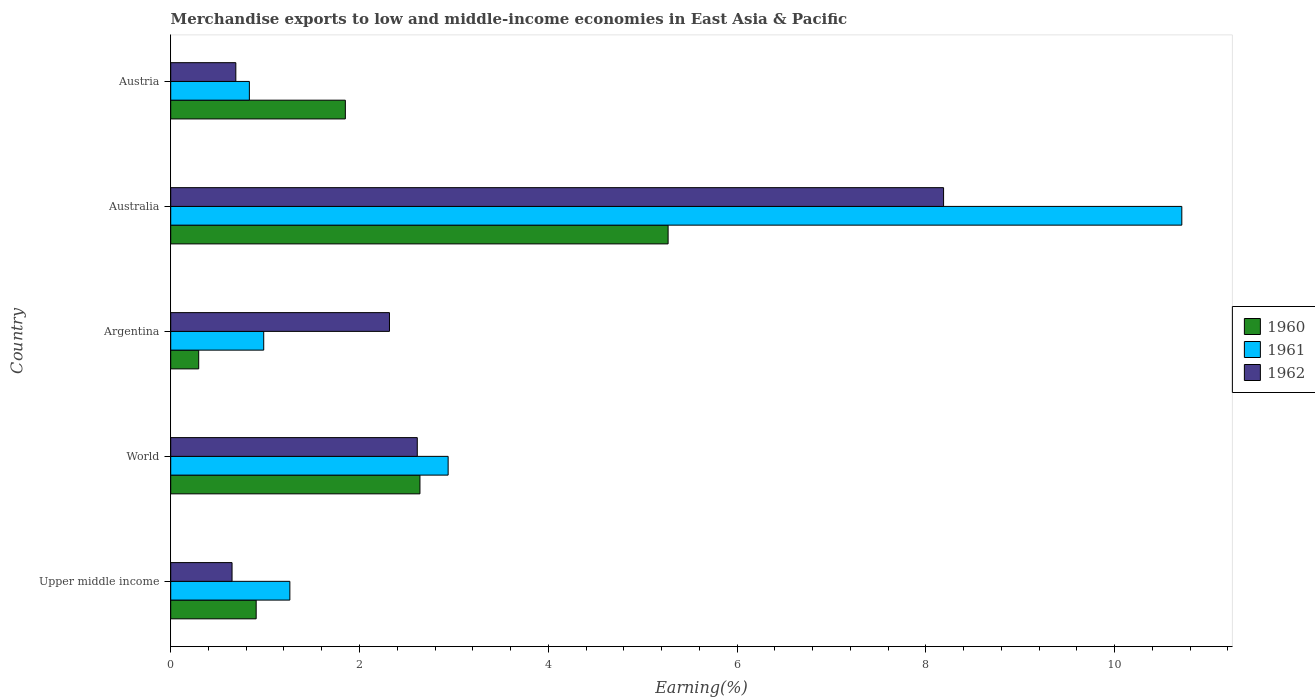How many groups of bars are there?
Your answer should be very brief. 5. Are the number of bars per tick equal to the number of legend labels?
Provide a succinct answer. Yes. Are the number of bars on each tick of the Y-axis equal?
Provide a succinct answer. Yes. How many bars are there on the 4th tick from the bottom?
Your answer should be compact. 3. In how many cases, is the number of bars for a given country not equal to the number of legend labels?
Provide a short and direct response. 0. What is the percentage of amount earned from merchandise exports in 1961 in Upper middle income?
Keep it short and to the point. 1.26. Across all countries, what is the maximum percentage of amount earned from merchandise exports in 1961?
Your response must be concise. 10.71. Across all countries, what is the minimum percentage of amount earned from merchandise exports in 1962?
Make the answer very short. 0.65. In which country was the percentage of amount earned from merchandise exports in 1961 minimum?
Make the answer very short. Austria. What is the total percentage of amount earned from merchandise exports in 1962 in the graph?
Keep it short and to the point. 14.46. What is the difference between the percentage of amount earned from merchandise exports in 1961 in Austria and that in Upper middle income?
Your answer should be very brief. -0.43. What is the difference between the percentage of amount earned from merchandise exports in 1962 in World and the percentage of amount earned from merchandise exports in 1961 in Austria?
Provide a short and direct response. 1.78. What is the average percentage of amount earned from merchandise exports in 1960 per country?
Keep it short and to the point. 2.19. What is the difference between the percentage of amount earned from merchandise exports in 1961 and percentage of amount earned from merchandise exports in 1962 in Argentina?
Make the answer very short. -1.33. What is the ratio of the percentage of amount earned from merchandise exports in 1961 in Austria to that in World?
Offer a terse response. 0.28. What is the difference between the highest and the second highest percentage of amount earned from merchandise exports in 1960?
Keep it short and to the point. 2.63. What is the difference between the highest and the lowest percentage of amount earned from merchandise exports in 1961?
Provide a short and direct response. 9.88. In how many countries, is the percentage of amount earned from merchandise exports in 1961 greater than the average percentage of amount earned from merchandise exports in 1961 taken over all countries?
Keep it short and to the point. 1. Is the sum of the percentage of amount earned from merchandise exports in 1961 in Australia and Austria greater than the maximum percentage of amount earned from merchandise exports in 1962 across all countries?
Your response must be concise. Yes. What does the 3rd bar from the bottom in Austria represents?
Make the answer very short. 1962. Are the values on the major ticks of X-axis written in scientific E-notation?
Ensure brevity in your answer.  No. Does the graph contain any zero values?
Your answer should be very brief. No. What is the title of the graph?
Ensure brevity in your answer.  Merchandise exports to low and middle-income economies in East Asia & Pacific. Does "1970" appear as one of the legend labels in the graph?
Your response must be concise. No. What is the label or title of the X-axis?
Your response must be concise. Earning(%). What is the label or title of the Y-axis?
Keep it short and to the point. Country. What is the Earning(%) of 1960 in Upper middle income?
Offer a very short reply. 0.91. What is the Earning(%) in 1961 in Upper middle income?
Give a very brief answer. 1.26. What is the Earning(%) of 1962 in Upper middle income?
Provide a short and direct response. 0.65. What is the Earning(%) of 1960 in World?
Offer a very short reply. 2.64. What is the Earning(%) in 1961 in World?
Give a very brief answer. 2.94. What is the Earning(%) in 1962 in World?
Provide a succinct answer. 2.61. What is the Earning(%) of 1960 in Argentina?
Your answer should be very brief. 0.3. What is the Earning(%) in 1961 in Argentina?
Your answer should be very brief. 0.99. What is the Earning(%) of 1962 in Argentina?
Ensure brevity in your answer.  2.32. What is the Earning(%) in 1960 in Australia?
Ensure brevity in your answer.  5.27. What is the Earning(%) in 1961 in Australia?
Ensure brevity in your answer.  10.71. What is the Earning(%) in 1962 in Australia?
Make the answer very short. 8.19. What is the Earning(%) of 1960 in Austria?
Give a very brief answer. 1.85. What is the Earning(%) of 1961 in Austria?
Make the answer very short. 0.83. What is the Earning(%) of 1962 in Austria?
Provide a short and direct response. 0.69. Across all countries, what is the maximum Earning(%) of 1960?
Your answer should be compact. 5.27. Across all countries, what is the maximum Earning(%) in 1961?
Ensure brevity in your answer.  10.71. Across all countries, what is the maximum Earning(%) in 1962?
Your answer should be very brief. 8.19. Across all countries, what is the minimum Earning(%) in 1960?
Provide a succinct answer. 0.3. Across all countries, what is the minimum Earning(%) in 1961?
Give a very brief answer. 0.83. Across all countries, what is the minimum Earning(%) of 1962?
Give a very brief answer. 0.65. What is the total Earning(%) of 1960 in the graph?
Offer a terse response. 10.96. What is the total Earning(%) in 1961 in the graph?
Provide a short and direct response. 16.73. What is the total Earning(%) of 1962 in the graph?
Make the answer very short. 14.46. What is the difference between the Earning(%) in 1960 in Upper middle income and that in World?
Your answer should be very brief. -1.74. What is the difference between the Earning(%) in 1961 in Upper middle income and that in World?
Make the answer very short. -1.68. What is the difference between the Earning(%) of 1962 in Upper middle income and that in World?
Keep it short and to the point. -1.96. What is the difference between the Earning(%) of 1960 in Upper middle income and that in Argentina?
Ensure brevity in your answer.  0.61. What is the difference between the Earning(%) of 1961 in Upper middle income and that in Argentina?
Make the answer very short. 0.28. What is the difference between the Earning(%) in 1962 in Upper middle income and that in Argentina?
Provide a succinct answer. -1.67. What is the difference between the Earning(%) in 1960 in Upper middle income and that in Australia?
Give a very brief answer. -4.36. What is the difference between the Earning(%) in 1961 in Upper middle income and that in Australia?
Make the answer very short. -9.45. What is the difference between the Earning(%) in 1962 in Upper middle income and that in Australia?
Offer a very short reply. -7.54. What is the difference between the Earning(%) of 1960 in Upper middle income and that in Austria?
Provide a succinct answer. -0.94. What is the difference between the Earning(%) in 1961 in Upper middle income and that in Austria?
Give a very brief answer. 0.43. What is the difference between the Earning(%) in 1962 in Upper middle income and that in Austria?
Keep it short and to the point. -0.04. What is the difference between the Earning(%) of 1960 in World and that in Argentina?
Your response must be concise. 2.34. What is the difference between the Earning(%) in 1961 in World and that in Argentina?
Give a very brief answer. 1.95. What is the difference between the Earning(%) of 1962 in World and that in Argentina?
Your response must be concise. 0.29. What is the difference between the Earning(%) in 1960 in World and that in Australia?
Offer a very short reply. -2.63. What is the difference between the Earning(%) in 1961 in World and that in Australia?
Your response must be concise. -7.77. What is the difference between the Earning(%) of 1962 in World and that in Australia?
Give a very brief answer. -5.58. What is the difference between the Earning(%) in 1960 in World and that in Austria?
Ensure brevity in your answer.  0.79. What is the difference between the Earning(%) in 1961 in World and that in Austria?
Provide a short and direct response. 2.11. What is the difference between the Earning(%) in 1962 in World and that in Austria?
Give a very brief answer. 1.92. What is the difference between the Earning(%) in 1960 in Argentina and that in Australia?
Provide a succinct answer. -4.97. What is the difference between the Earning(%) of 1961 in Argentina and that in Australia?
Your answer should be compact. -9.73. What is the difference between the Earning(%) in 1962 in Argentina and that in Australia?
Your answer should be compact. -5.87. What is the difference between the Earning(%) of 1960 in Argentina and that in Austria?
Offer a very short reply. -1.55. What is the difference between the Earning(%) of 1961 in Argentina and that in Austria?
Your answer should be very brief. 0.15. What is the difference between the Earning(%) of 1962 in Argentina and that in Austria?
Your answer should be compact. 1.63. What is the difference between the Earning(%) of 1960 in Australia and that in Austria?
Your answer should be compact. 3.42. What is the difference between the Earning(%) in 1961 in Australia and that in Austria?
Ensure brevity in your answer.  9.88. What is the difference between the Earning(%) of 1962 in Australia and that in Austria?
Your answer should be compact. 7.5. What is the difference between the Earning(%) of 1960 in Upper middle income and the Earning(%) of 1961 in World?
Offer a very short reply. -2.03. What is the difference between the Earning(%) of 1960 in Upper middle income and the Earning(%) of 1962 in World?
Offer a terse response. -1.71. What is the difference between the Earning(%) of 1961 in Upper middle income and the Earning(%) of 1962 in World?
Keep it short and to the point. -1.35. What is the difference between the Earning(%) of 1960 in Upper middle income and the Earning(%) of 1961 in Argentina?
Your response must be concise. -0.08. What is the difference between the Earning(%) of 1960 in Upper middle income and the Earning(%) of 1962 in Argentina?
Provide a succinct answer. -1.41. What is the difference between the Earning(%) of 1961 in Upper middle income and the Earning(%) of 1962 in Argentina?
Offer a terse response. -1.06. What is the difference between the Earning(%) in 1960 in Upper middle income and the Earning(%) in 1961 in Australia?
Your answer should be compact. -9.81. What is the difference between the Earning(%) of 1960 in Upper middle income and the Earning(%) of 1962 in Australia?
Your response must be concise. -7.28. What is the difference between the Earning(%) of 1961 in Upper middle income and the Earning(%) of 1962 in Australia?
Offer a terse response. -6.93. What is the difference between the Earning(%) in 1960 in Upper middle income and the Earning(%) in 1961 in Austria?
Keep it short and to the point. 0.07. What is the difference between the Earning(%) in 1960 in Upper middle income and the Earning(%) in 1962 in Austria?
Your answer should be very brief. 0.22. What is the difference between the Earning(%) of 1961 in Upper middle income and the Earning(%) of 1962 in Austria?
Keep it short and to the point. 0.57. What is the difference between the Earning(%) in 1960 in World and the Earning(%) in 1961 in Argentina?
Your response must be concise. 1.66. What is the difference between the Earning(%) in 1960 in World and the Earning(%) in 1962 in Argentina?
Your response must be concise. 0.32. What is the difference between the Earning(%) in 1961 in World and the Earning(%) in 1962 in Argentina?
Provide a succinct answer. 0.62. What is the difference between the Earning(%) of 1960 in World and the Earning(%) of 1961 in Australia?
Provide a short and direct response. -8.07. What is the difference between the Earning(%) in 1960 in World and the Earning(%) in 1962 in Australia?
Your answer should be very brief. -5.55. What is the difference between the Earning(%) of 1961 in World and the Earning(%) of 1962 in Australia?
Keep it short and to the point. -5.25. What is the difference between the Earning(%) in 1960 in World and the Earning(%) in 1961 in Austria?
Offer a terse response. 1.81. What is the difference between the Earning(%) in 1960 in World and the Earning(%) in 1962 in Austria?
Provide a succinct answer. 1.95. What is the difference between the Earning(%) of 1961 in World and the Earning(%) of 1962 in Austria?
Your answer should be very brief. 2.25. What is the difference between the Earning(%) in 1960 in Argentina and the Earning(%) in 1961 in Australia?
Offer a terse response. -10.42. What is the difference between the Earning(%) of 1960 in Argentina and the Earning(%) of 1962 in Australia?
Your response must be concise. -7.89. What is the difference between the Earning(%) of 1961 in Argentina and the Earning(%) of 1962 in Australia?
Provide a short and direct response. -7.2. What is the difference between the Earning(%) in 1960 in Argentina and the Earning(%) in 1961 in Austria?
Keep it short and to the point. -0.54. What is the difference between the Earning(%) of 1960 in Argentina and the Earning(%) of 1962 in Austria?
Provide a short and direct response. -0.39. What is the difference between the Earning(%) of 1961 in Argentina and the Earning(%) of 1962 in Austria?
Ensure brevity in your answer.  0.3. What is the difference between the Earning(%) in 1960 in Australia and the Earning(%) in 1961 in Austria?
Give a very brief answer. 4.44. What is the difference between the Earning(%) of 1960 in Australia and the Earning(%) of 1962 in Austria?
Ensure brevity in your answer.  4.58. What is the difference between the Earning(%) of 1961 in Australia and the Earning(%) of 1962 in Austria?
Provide a short and direct response. 10.02. What is the average Earning(%) of 1960 per country?
Your response must be concise. 2.19. What is the average Earning(%) in 1961 per country?
Offer a terse response. 3.35. What is the average Earning(%) in 1962 per country?
Your answer should be very brief. 2.89. What is the difference between the Earning(%) of 1960 and Earning(%) of 1961 in Upper middle income?
Offer a terse response. -0.36. What is the difference between the Earning(%) of 1960 and Earning(%) of 1962 in Upper middle income?
Ensure brevity in your answer.  0.26. What is the difference between the Earning(%) in 1961 and Earning(%) in 1962 in Upper middle income?
Offer a terse response. 0.61. What is the difference between the Earning(%) in 1960 and Earning(%) in 1961 in World?
Your answer should be very brief. -0.3. What is the difference between the Earning(%) of 1960 and Earning(%) of 1962 in World?
Ensure brevity in your answer.  0.03. What is the difference between the Earning(%) of 1961 and Earning(%) of 1962 in World?
Keep it short and to the point. 0.33. What is the difference between the Earning(%) in 1960 and Earning(%) in 1961 in Argentina?
Ensure brevity in your answer.  -0.69. What is the difference between the Earning(%) of 1960 and Earning(%) of 1962 in Argentina?
Keep it short and to the point. -2.02. What is the difference between the Earning(%) of 1961 and Earning(%) of 1962 in Argentina?
Provide a short and direct response. -1.33. What is the difference between the Earning(%) of 1960 and Earning(%) of 1961 in Australia?
Offer a terse response. -5.44. What is the difference between the Earning(%) in 1960 and Earning(%) in 1962 in Australia?
Keep it short and to the point. -2.92. What is the difference between the Earning(%) in 1961 and Earning(%) in 1962 in Australia?
Offer a terse response. 2.52. What is the difference between the Earning(%) in 1960 and Earning(%) in 1961 in Austria?
Your answer should be compact. 1.02. What is the difference between the Earning(%) of 1960 and Earning(%) of 1962 in Austria?
Give a very brief answer. 1.16. What is the difference between the Earning(%) of 1961 and Earning(%) of 1962 in Austria?
Your response must be concise. 0.14. What is the ratio of the Earning(%) of 1960 in Upper middle income to that in World?
Your answer should be very brief. 0.34. What is the ratio of the Earning(%) in 1961 in Upper middle income to that in World?
Your answer should be very brief. 0.43. What is the ratio of the Earning(%) in 1962 in Upper middle income to that in World?
Your response must be concise. 0.25. What is the ratio of the Earning(%) of 1960 in Upper middle income to that in Argentina?
Your answer should be compact. 3.05. What is the ratio of the Earning(%) in 1961 in Upper middle income to that in Argentina?
Offer a terse response. 1.28. What is the ratio of the Earning(%) in 1962 in Upper middle income to that in Argentina?
Your response must be concise. 0.28. What is the ratio of the Earning(%) of 1960 in Upper middle income to that in Australia?
Provide a short and direct response. 0.17. What is the ratio of the Earning(%) in 1961 in Upper middle income to that in Australia?
Make the answer very short. 0.12. What is the ratio of the Earning(%) of 1962 in Upper middle income to that in Australia?
Your answer should be compact. 0.08. What is the ratio of the Earning(%) in 1960 in Upper middle income to that in Austria?
Ensure brevity in your answer.  0.49. What is the ratio of the Earning(%) in 1961 in Upper middle income to that in Austria?
Your answer should be compact. 1.51. What is the ratio of the Earning(%) in 1962 in Upper middle income to that in Austria?
Your response must be concise. 0.94. What is the ratio of the Earning(%) of 1960 in World to that in Argentina?
Make the answer very short. 8.9. What is the ratio of the Earning(%) in 1961 in World to that in Argentina?
Your response must be concise. 2.98. What is the ratio of the Earning(%) in 1962 in World to that in Argentina?
Your answer should be compact. 1.13. What is the ratio of the Earning(%) in 1960 in World to that in Australia?
Ensure brevity in your answer.  0.5. What is the ratio of the Earning(%) in 1961 in World to that in Australia?
Make the answer very short. 0.27. What is the ratio of the Earning(%) of 1962 in World to that in Australia?
Your answer should be very brief. 0.32. What is the ratio of the Earning(%) of 1960 in World to that in Austria?
Your answer should be very brief. 1.43. What is the ratio of the Earning(%) in 1961 in World to that in Austria?
Make the answer very short. 3.53. What is the ratio of the Earning(%) of 1962 in World to that in Austria?
Offer a terse response. 3.79. What is the ratio of the Earning(%) of 1960 in Argentina to that in Australia?
Provide a short and direct response. 0.06. What is the ratio of the Earning(%) in 1961 in Argentina to that in Australia?
Keep it short and to the point. 0.09. What is the ratio of the Earning(%) of 1962 in Argentina to that in Australia?
Ensure brevity in your answer.  0.28. What is the ratio of the Earning(%) of 1960 in Argentina to that in Austria?
Offer a terse response. 0.16. What is the ratio of the Earning(%) of 1961 in Argentina to that in Austria?
Keep it short and to the point. 1.18. What is the ratio of the Earning(%) of 1962 in Argentina to that in Austria?
Your answer should be compact. 3.36. What is the ratio of the Earning(%) of 1960 in Australia to that in Austria?
Offer a very short reply. 2.85. What is the ratio of the Earning(%) in 1961 in Australia to that in Austria?
Provide a short and direct response. 12.85. What is the ratio of the Earning(%) of 1962 in Australia to that in Austria?
Provide a short and direct response. 11.87. What is the difference between the highest and the second highest Earning(%) of 1960?
Provide a succinct answer. 2.63. What is the difference between the highest and the second highest Earning(%) of 1961?
Keep it short and to the point. 7.77. What is the difference between the highest and the second highest Earning(%) in 1962?
Give a very brief answer. 5.58. What is the difference between the highest and the lowest Earning(%) in 1960?
Provide a short and direct response. 4.97. What is the difference between the highest and the lowest Earning(%) of 1961?
Your answer should be very brief. 9.88. What is the difference between the highest and the lowest Earning(%) of 1962?
Your answer should be compact. 7.54. 